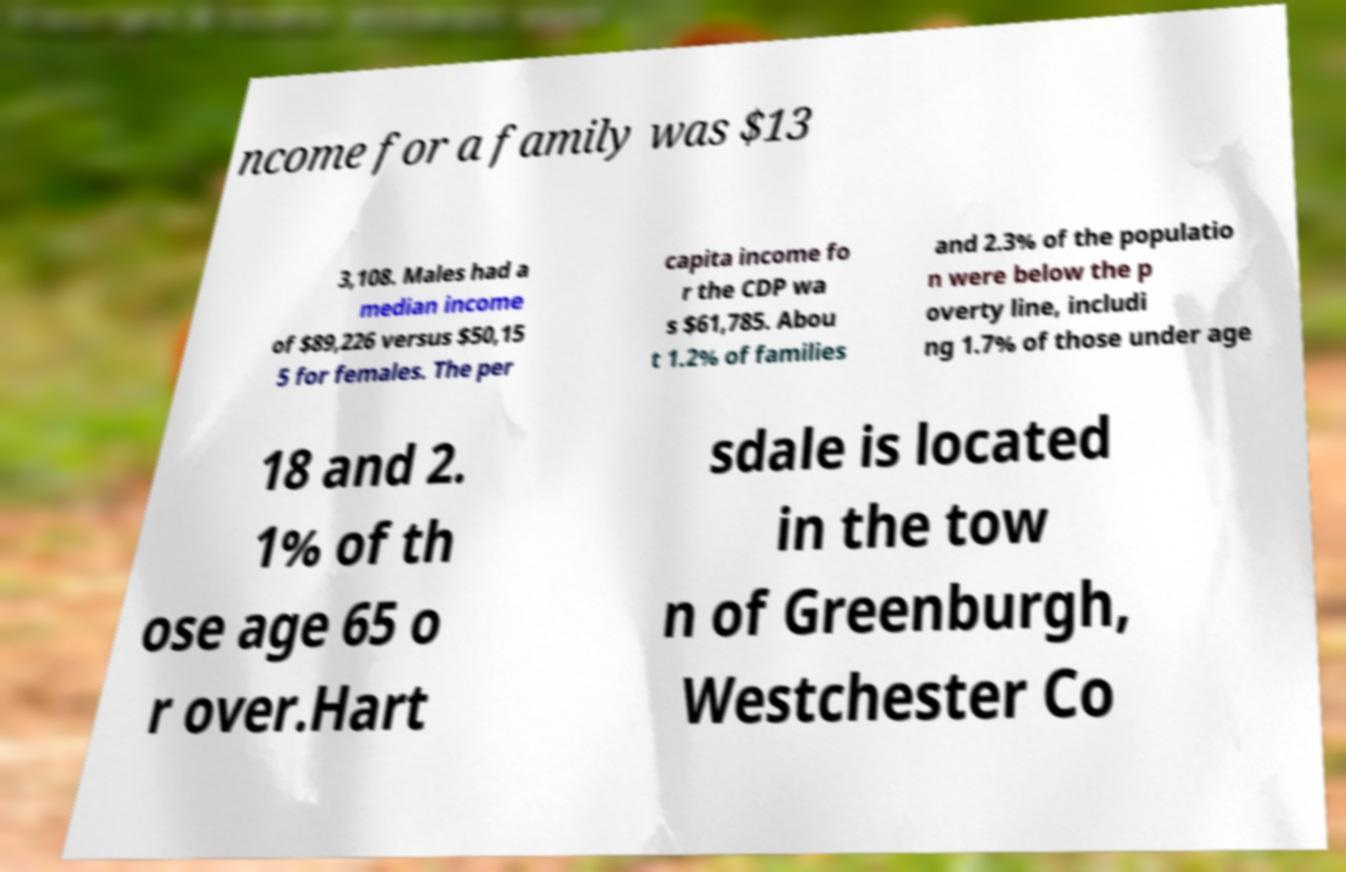For documentation purposes, I need the text within this image transcribed. Could you provide that? ncome for a family was $13 3,108. Males had a median income of $89,226 versus $50,15 5 for females. The per capita income fo r the CDP wa s $61,785. Abou t 1.2% of families and 2.3% of the populatio n were below the p overty line, includi ng 1.7% of those under age 18 and 2. 1% of th ose age 65 o r over.Hart sdale is located in the tow n of Greenburgh, Westchester Co 